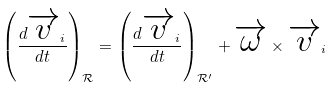Convert formula to latex. <formula><loc_0><loc_0><loc_500><loc_500>\left ( \frac { d \overrightarrow { v } _ { i } } { d t } \right ) _ { \mathcal { R } } = \left ( \frac { d \overrightarrow { v } _ { i } } { d t } \right ) _ { \mathcal { R ^ { \prime } } } + \overrightarrow { \omega } \times \overrightarrow { v } _ { i }</formula> 